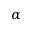Convert formula to latex. <formula><loc_0><loc_0><loc_500><loc_500>\alpha</formula> 